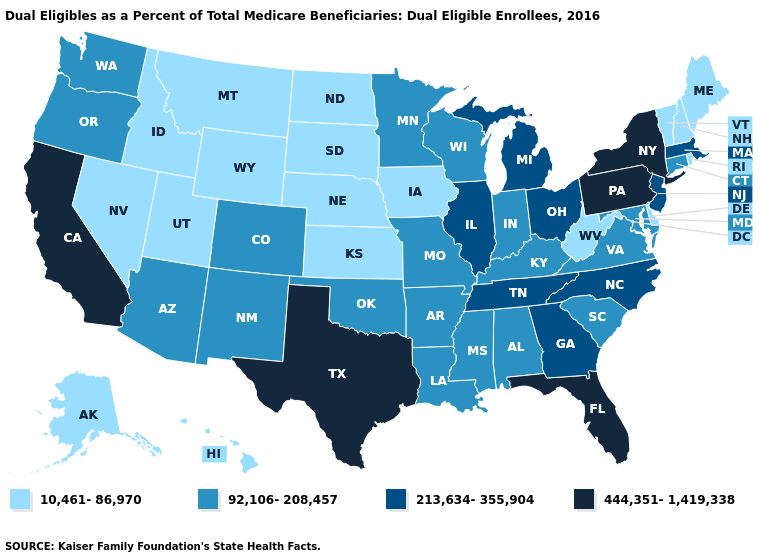Name the states that have a value in the range 213,634-355,904?
Keep it brief. Georgia, Illinois, Massachusetts, Michigan, New Jersey, North Carolina, Ohio, Tennessee. Name the states that have a value in the range 213,634-355,904?
Concise answer only. Georgia, Illinois, Massachusetts, Michigan, New Jersey, North Carolina, Ohio, Tennessee. Does Massachusetts have the highest value in the Northeast?
Be succinct. No. Does South Dakota have a lower value than Oklahoma?
Give a very brief answer. Yes. What is the highest value in states that border Vermont?
Short answer required. 444,351-1,419,338. What is the value of Florida?
Concise answer only. 444,351-1,419,338. Which states have the highest value in the USA?
Short answer required. California, Florida, New York, Pennsylvania, Texas. Among the states that border Indiana , which have the highest value?
Quick response, please. Illinois, Michigan, Ohio. How many symbols are there in the legend?
Answer briefly. 4. Name the states that have a value in the range 213,634-355,904?
Answer briefly. Georgia, Illinois, Massachusetts, Michigan, New Jersey, North Carolina, Ohio, Tennessee. What is the value of Delaware?
Write a very short answer. 10,461-86,970. Does Ohio have a lower value than Louisiana?
Quick response, please. No. What is the lowest value in the MidWest?
Write a very short answer. 10,461-86,970. Name the states that have a value in the range 10,461-86,970?
Concise answer only. Alaska, Delaware, Hawaii, Idaho, Iowa, Kansas, Maine, Montana, Nebraska, Nevada, New Hampshire, North Dakota, Rhode Island, South Dakota, Utah, Vermont, West Virginia, Wyoming. What is the highest value in the MidWest ?
Write a very short answer. 213,634-355,904. 